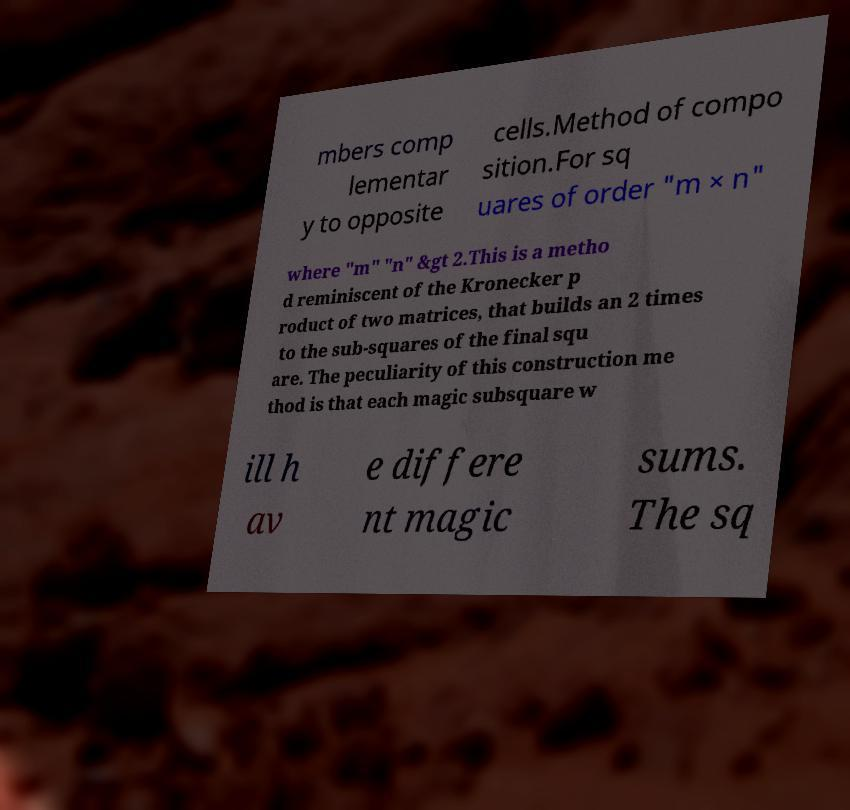What messages or text are displayed in this image? I need them in a readable, typed format. mbers comp lementar y to opposite cells.Method of compo sition.For sq uares of order "m × n" where "m" "n" &gt 2.This is a metho d reminiscent of the Kronecker p roduct of two matrices, that builds an 2 times to the sub-squares of the final squ are. The peculiarity of this construction me thod is that each magic subsquare w ill h av e differe nt magic sums. The sq 